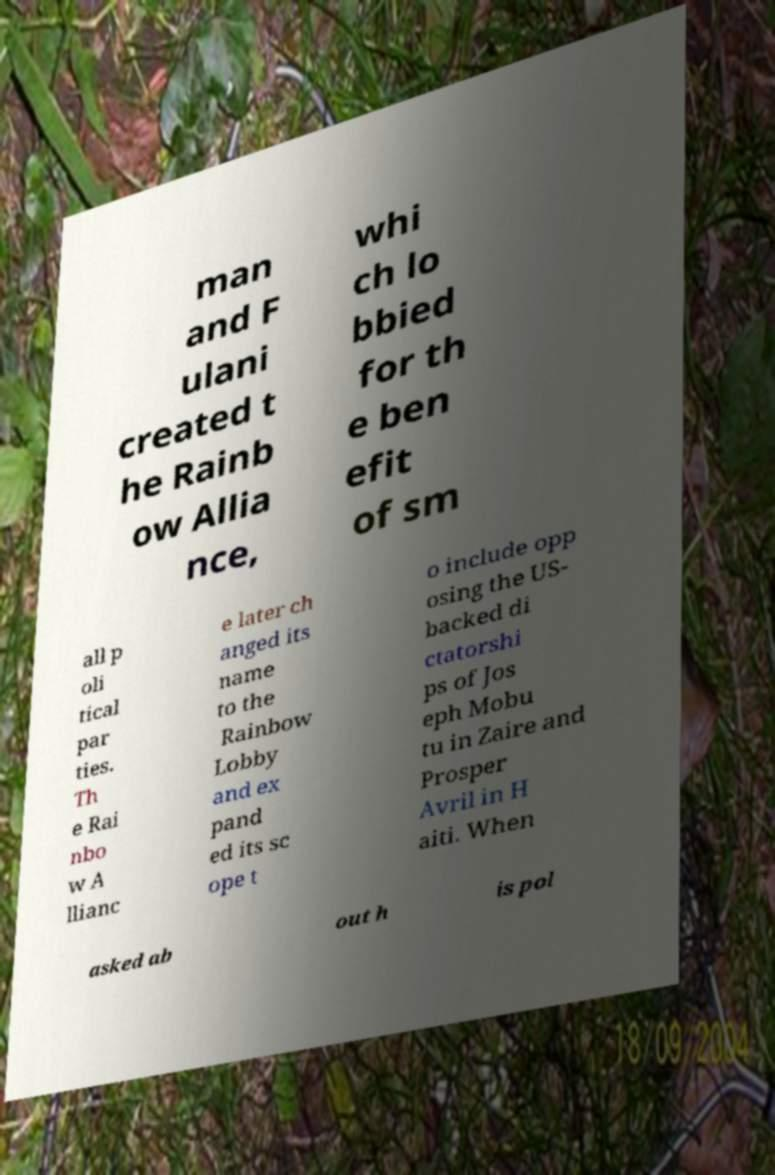Can you accurately transcribe the text from the provided image for me? man and F ulani created t he Rainb ow Allia nce, whi ch lo bbied for th e ben efit of sm all p oli tical par ties. Th e Rai nbo w A llianc e later ch anged its name to the Rainbow Lobby and ex pand ed its sc ope t o include opp osing the US- backed di ctatorshi ps of Jos eph Mobu tu in Zaire and Prosper Avril in H aiti. When asked ab out h is pol 